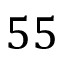Convert formula to latex. <formula><loc_0><loc_0><loc_500><loc_500>5 5</formula> 